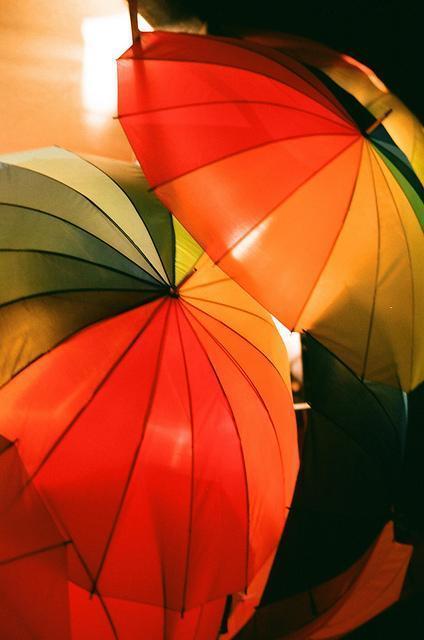How many umbrellas are in the picture?
Give a very brief answer. 4. How many people are shown?
Give a very brief answer. 0. 